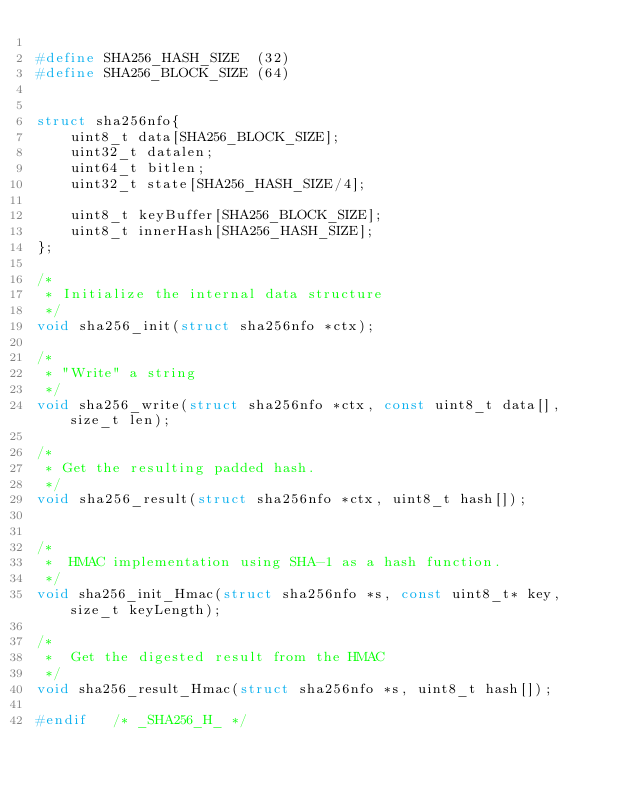Convert code to text. <code><loc_0><loc_0><loc_500><loc_500><_C_>
#define SHA256_HASH_SIZE  (32)
#define SHA256_BLOCK_SIZE (64)


struct sha256nfo{
	uint8_t data[SHA256_BLOCK_SIZE];
	uint32_t datalen;
	uint64_t bitlen;
	uint32_t state[SHA256_HASH_SIZE/4];

	uint8_t keyBuffer[SHA256_BLOCK_SIZE];
	uint8_t innerHash[SHA256_HASH_SIZE];
};

/*
 * Initialize the internal data structure
 */
void sha256_init(struct sha256nfo *ctx);

/*
 * "Write" a string 
 */
void sha256_write(struct sha256nfo *ctx, const uint8_t data[], size_t len);

/*
 * Get the resulting padded hash. 
 */
void sha256_result(struct sha256nfo *ctx, uint8_t hash[]);


/*
 *  HMAC implementation using SHA-1 as a hash function.
 */
void sha256_init_Hmac(struct sha256nfo *s, const uint8_t* key, size_t keyLength);

/*
 *  Get the digested result from the HMAC
 */
void sha256_result_Hmac(struct sha256nfo *s, uint8_t hash[]);

#endif   /* _SHA256_H_ */
</code> 